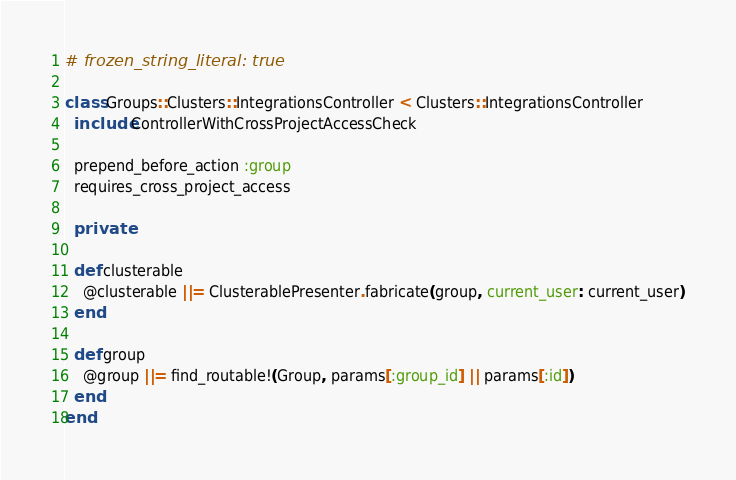<code> <loc_0><loc_0><loc_500><loc_500><_Ruby_># frozen_string_literal: true

class Groups::Clusters::IntegrationsController < Clusters::IntegrationsController
  include ControllerWithCrossProjectAccessCheck

  prepend_before_action :group
  requires_cross_project_access

  private

  def clusterable
    @clusterable ||= ClusterablePresenter.fabricate(group, current_user: current_user)
  end

  def group
    @group ||= find_routable!(Group, params[:group_id] || params[:id])
  end
end
</code> 